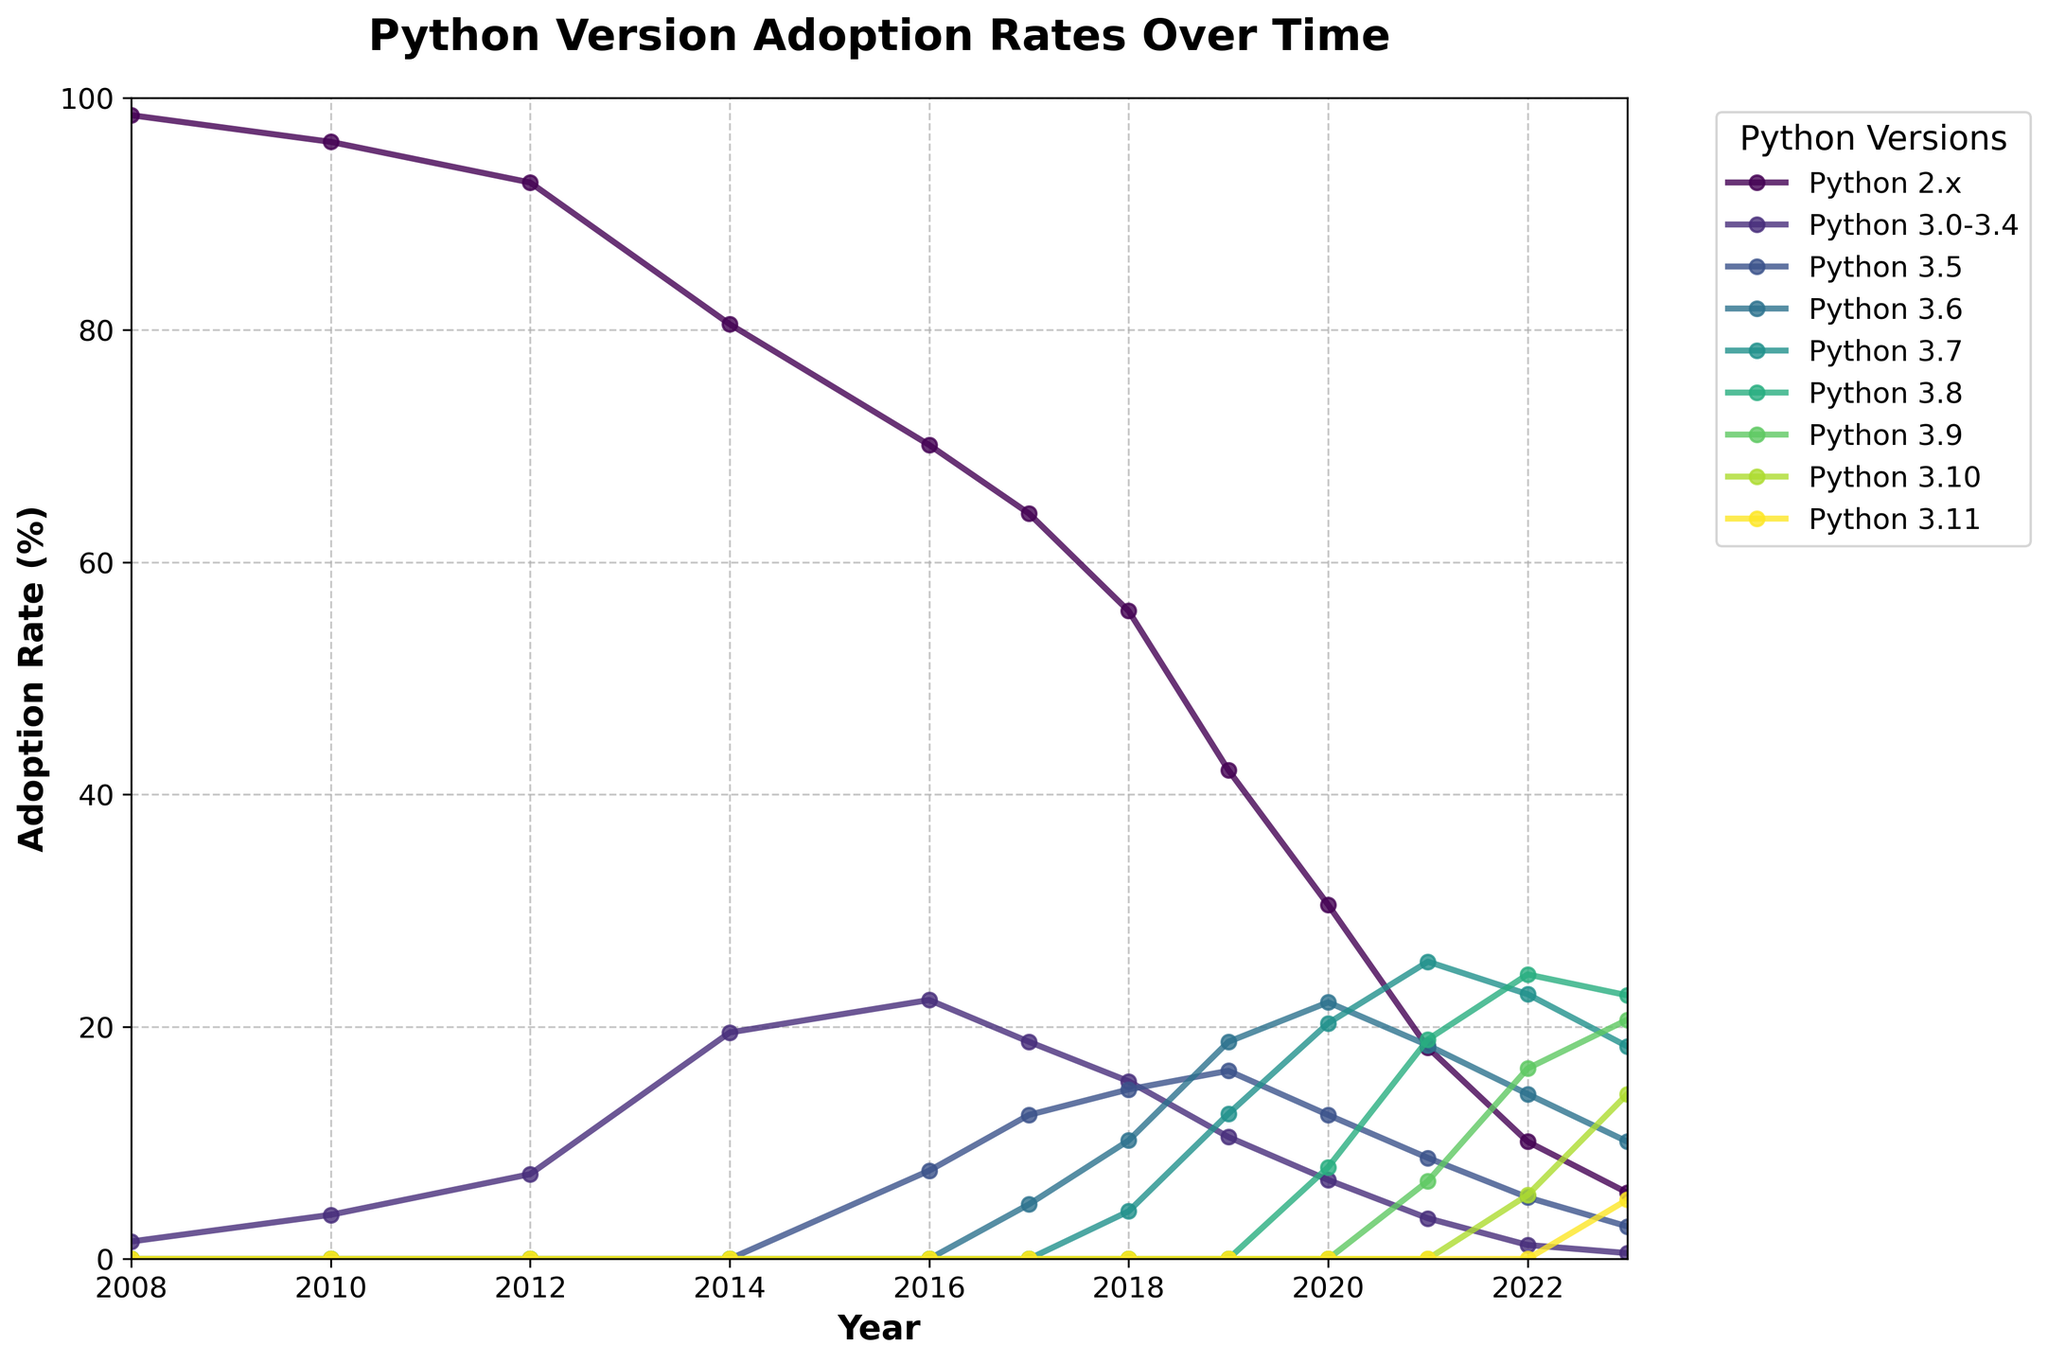What was the adoption rate of Python 2.x in 2008 compared to 2023? Compare the adoption rate of Python 2.x in 2008 and 2023 by looking at the start and end points of the line for Python 2.x. The rate in 2008 is 98.5% and it decreases to 5.7% in 2023.
Answer: In 2008, it was 98.5%, and in 2023, it was 5.7% Which year did Python 3.6 surpass Python 2.x in adoption rate? Identify the year where the line for Python 3.6 crosses above the line for Python 2.x. This visually shows the first year when Python 3.6 was more adopted than Python 2.x. In the figure, it occurred in 2019.
Answer: 2019 What is the difference in adoption rates between Python 3.8 and Python 3.9 in 2023? Look at the endpoints of the lines for Python 3.8 and Python 3.9 in 2023. Python 3.8 has an adoption rate of 22.7%, and Python 3.9 has 20.6%. Subtract 20.6 from 22.7 to find the difference.
Answer: 2.1% Which Python version had the highest adoption rate in 2022? Identify the line that reaches the highest point in 2022. The line for Python 3.8 reaches the highest point with an adoption rate of 24.5%.
Answer: Python 3.8 What is the average adoption rate of Python 3.6 from 2016 to 2023? Add the adoption rates of Python 3.6 from 2016 to 2023, then divide by the number of years (8 years). The rates are 0 (2016), 4.7 (2017), 10.2 (2018), 18.7 (2019), 22.1 (2020), 18.4 (2021), 14.2 (2022), and 10.1 (2023). Average = (0 + 4.7 + 10.2 + 18.7 + 22.1 + 18.4 + 14.2 + 10.1) / 8 = 12.3%.
Answer: 12.3% In which year did Python 3.x versions (from 3.0 to 3.11) collectively surpass Python 2.x in adoption rate? Add the adoption rates of all Python 3.x versions for each year and compare with Python 2.x. The collective rates surpass Python 2.x in 2017.
Answer: 2017 Which Python version shows the most consistent increase in adoption rate from its release until 2023? Identify the trend for each line. Python 3.8 shows a steady and consistent increase from its appearance around 2019 till 2023.
Answer: Python 3.8 By how much did the adoption rate of Python 2.x decrease from 2014 to 2016? Subtract the 2016 rate from the 2014 rate for Python 2.x. The adoption rates are 80.5% in 2014 and 70.1% in 2016. The decrease is 80.5 - 70.1 = 10.4%.
Answer: 10.4% What trend do you observe for Python 3.10 and Python 3.11 after their introduction? Check when these versions appear and how their adoption rates change over time. Both show an increase, with Python 3.10 reaching 14.2% and Python 3.11 reaching 5.1% by 2023.
Answer: Increasing 